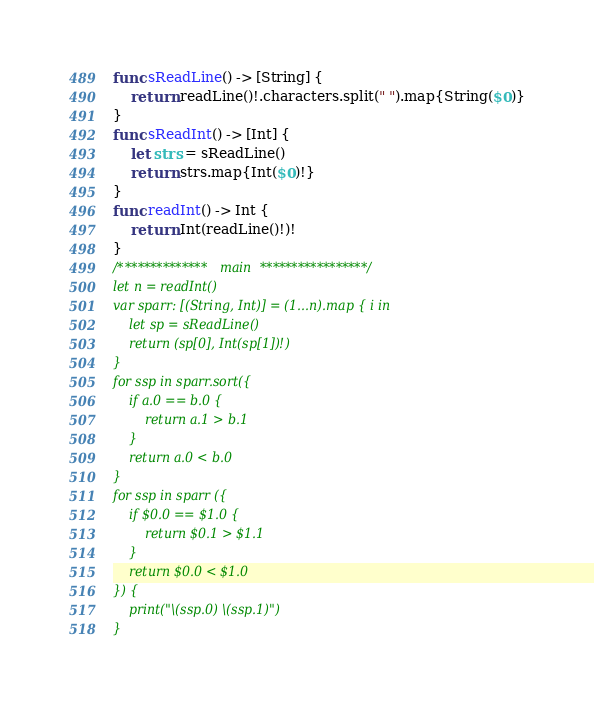<code> <loc_0><loc_0><loc_500><loc_500><_Swift_>func sReadLine() -> [String] {
    return readLine()!.characters.split(" ").map{String($0)}
}
func sReadInt() -> [Int] {
    let strs = sReadLine()
    return strs.map{Int($0)!}
}
func readInt() -> Int {
    return Int(readLine()!)!
}
/************** main *****************/
let n = readInt()
var sparr: [(String, Int)] = (1...n).map { i in
    let sp = sReadLine()
    return (sp[0], Int(sp[1])!)
}
for ssp in sparr.sort({
    if a.0 == b.0 {
        return a.1 > b.1
    }
    return a.0 < b.0
}
for ssp in sparr ({
    if $0.0 == $1.0 {
        return $0.1 > $1.1
    }
    return $0.0 < $1.0
}) {
    print("\(ssp.0) \(ssp.1)")
}
</code> 